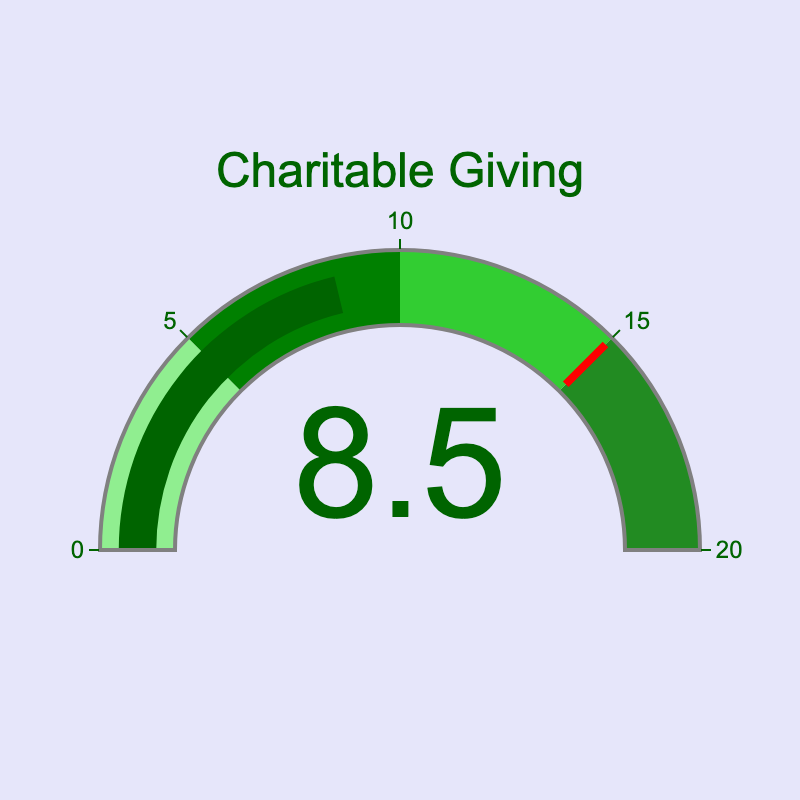What is the title of the gauge chart? The title of the gauge chart is displayed prominently in the center of the figure just above the gauge itself.
Answer: Charitable Giving What percent of the income is allocated to charitable giving? The gauge in the figure clearly points to the number displaying the percentage of income allocated to charitable giving.
Answer: 8.5% What is the maximum range displayed on the gauge? The outer ring of the gauge shows numbers from 0 to a maximum value. This range is displayed around the circumference of the gauge.
Answer: 20 In which color range does the percentage for charitable giving fall? Observing the gauge, the section where the value 8.5 lies is colored differently to indicate specific ranges.
Answer: Green How much more percentage does the income need to reach the gauge's threshold value? To find this, we subtract the current value from the threshold indicated by the red line. The threshold value is clearly marked.
Answer: 6.5 What is the thickness of the threshold line on the gauge? The threshold line is a distinct line within the gauge, colored differently from other elements, and its thickness can be visually observed.
Answer: 0.75 What is the history or significance of using a gauge representation for data like this? Gauge charts are often used for displaying information where progress towards a specific goal or limit is relevant, analogous to speedometers or other dials, which makes understanding the proportional allocation instantly clear.
Answer: To show proportional progress Would you say charitable giving is closer to the lower or upper extreme of the gauge? By visually inspecting where 8.5 lies compared to the range, we can determine whether it is closer to the minimum (0) or maximum (20).
Answer: Lower extreme What is the background color of the figure? The color surrounding the gauge and the entire background of the plot is visible and can be identified.
Answer: Lavender 